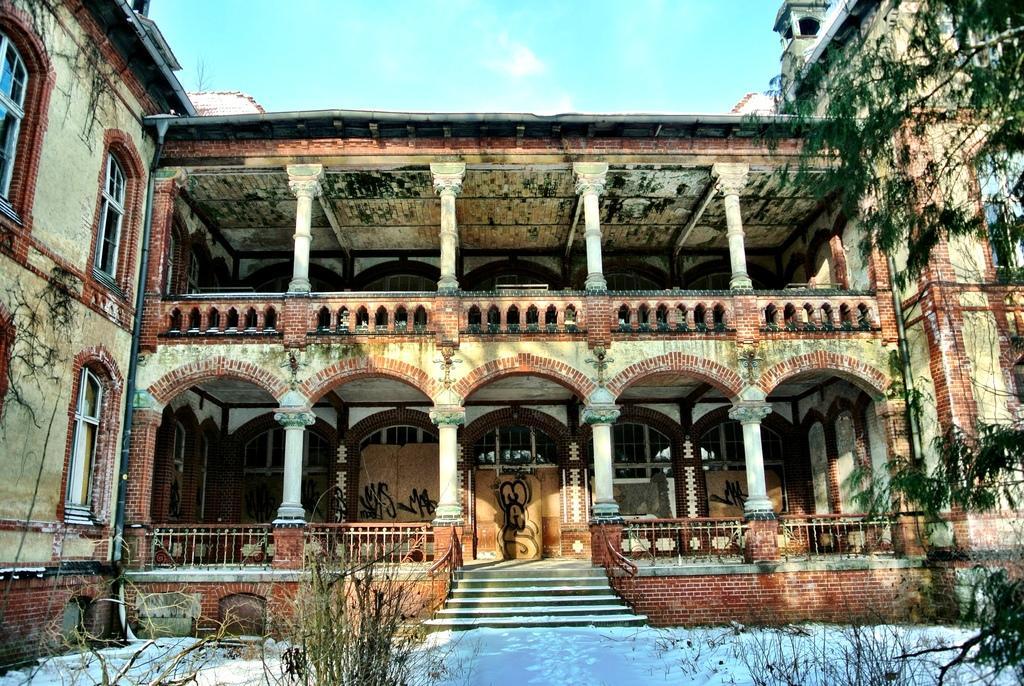Could you give a brief overview of what you see in this image? In this image I can see the building, windows, pillars, snow, stairs, trees and the sky. 